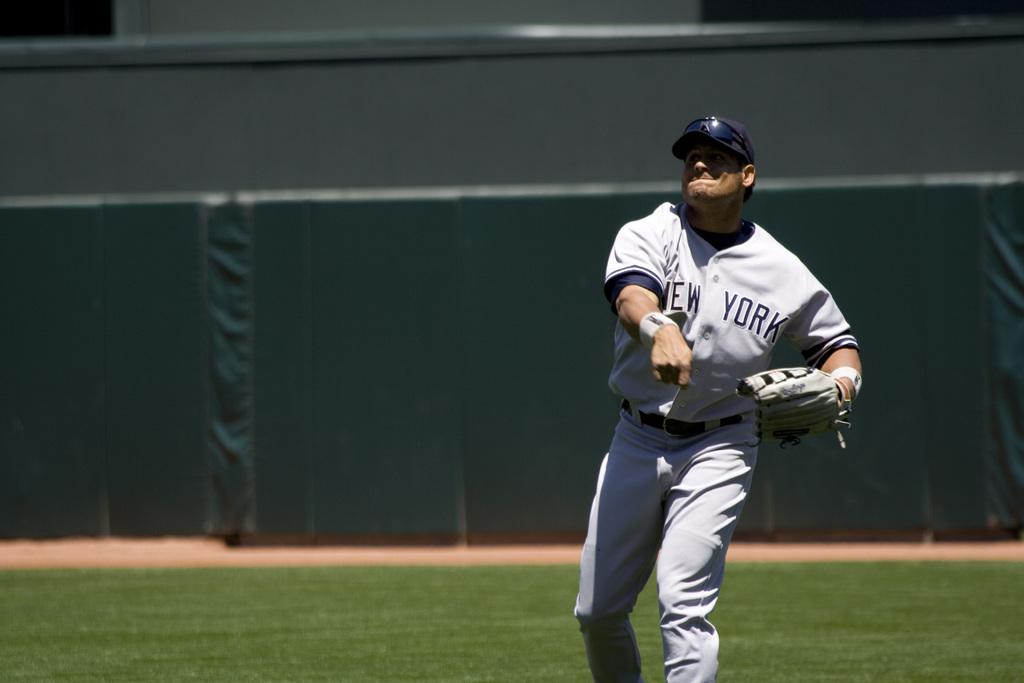<image>
Write a terse but informative summary of the picture. A New York Yankee outfielder throws the ball back infield. 